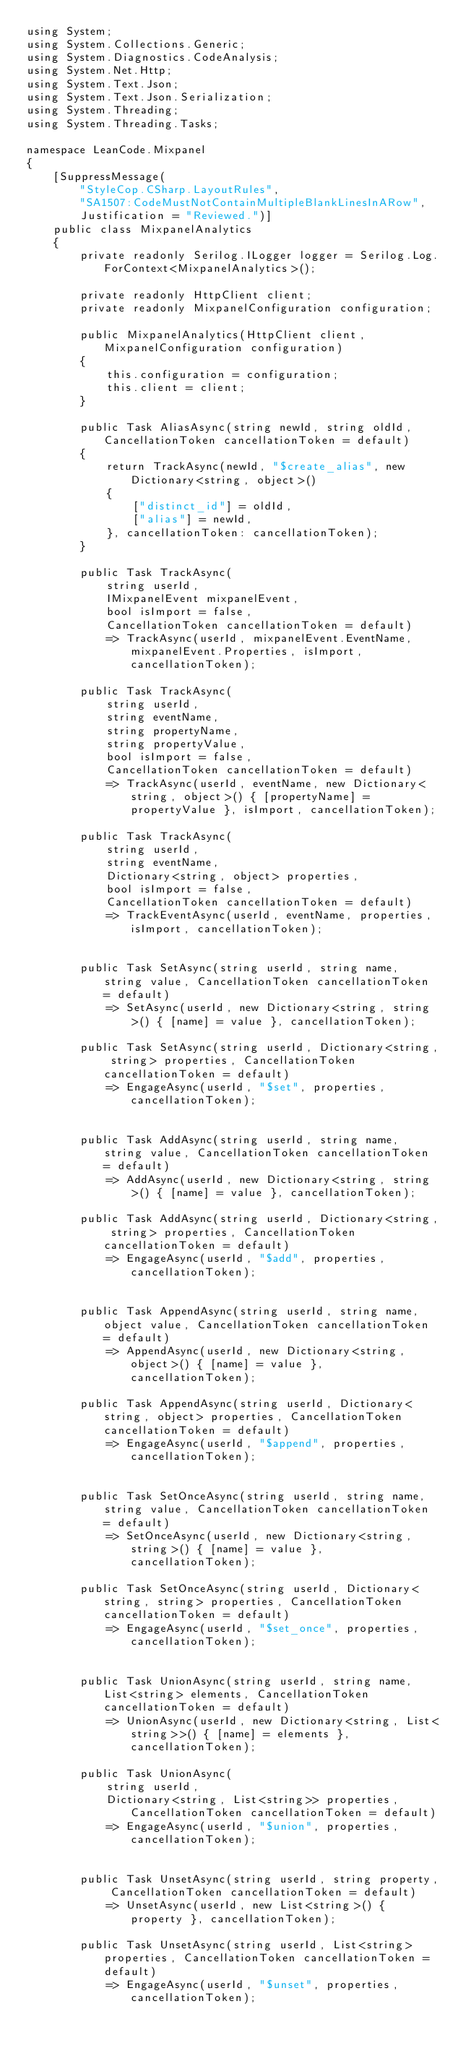Convert code to text. <code><loc_0><loc_0><loc_500><loc_500><_C#_>using System;
using System.Collections.Generic;
using System.Diagnostics.CodeAnalysis;
using System.Net.Http;
using System.Text.Json;
using System.Text.Json.Serialization;
using System.Threading;
using System.Threading.Tasks;

namespace LeanCode.Mixpanel
{
    [SuppressMessage(
        "StyleCop.CSharp.LayoutRules",
        "SA1507:CodeMustNotContainMultipleBlankLinesInARow",
        Justification = "Reviewed.")]
    public class MixpanelAnalytics
    {
        private readonly Serilog.ILogger logger = Serilog.Log.ForContext<MixpanelAnalytics>();

        private readonly HttpClient client;
        private readonly MixpanelConfiguration configuration;

        public MixpanelAnalytics(HttpClient client, MixpanelConfiguration configuration)
        {
            this.configuration = configuration;
            this.client = client;
        }

        public Task AliasAsync(string newId, string oldId, CancellationToken cancellationToken = default)
        {
            return TrackAsync(newId, "$create_alias", new Dictionary<string, object>()
            {
                ["distinct_id"] = oldId,
                ["alias"] = newId,
            }, cancellationToken: cancellationToken);
        }

        public Task TrackAsync(
            string userId,
            IMixpanelEvent mixpanelEvent,
            bool isImport = false,
            CancellationToken cancellationToken = default)
            => TrackAsync(userId, mixpanelEvent.EventName, mixpanelEvent.Properties, isImport, cancellationToken);

        public Task TrackAsync(
            string userId,
            string eventName,
            string propertyName,
            string propertyValue,
            bool isImport = false,
            CancellationToken cancellationToken = default)
            => TrackAsync(userId, eventName, new Dictionary<string, object>() { [propertyName] = propertyValue }, isImport, cancellationToken);

        public Task TrackAsync(
            string userId,
            string eventName,
            Dictionary<string, object> properties,
            bool isImport = false,
            CancellationToken cancellationToken = default)
            => TrackEventAsync(userId, eventName, properties, isImport, cancellationToken);


        public Task SetAsync(string userId, string name, string value, CancellationToken cancellationToken = default)
            => SetAsync(userId, new Dictionary<string, string>() { [name] = value }, cancellationToken);

        public Task SetAsync(string userId, Dictionary<string, string> properties, CancellationToken cancellationToken = default)
            => EngageAsync(userId, "$set", properties, cancellationToken);


        public Task AddAsync(string userId, string name, string value, CancellationToken cancellationToken = default)
            => AddAsync(userId, new Dictionary<string, string>() { [name] = value }, cancellationToken);

        public Task AddAsync(string userId, Dictionary<string, string> properties, CancellationToken cancellationToken = default)
            => EngageAsync(userId, "$add", properties, cancellationToken);


        public Task AppendAsync(string userId, string name, object value, CancellationToken cancellationToken = default)
            => AppendAsync(userId, new Dictionary<string, object>() { [name] = value }, cancellationToken);

        public Task AppendAsync(string userId, Dictionary<string, object> properties, CancellationToken cancellationToken = default)
            => EngageAsync(userId, "$append", properties, cancellationToken);


        public Task SetOnceAsync(string userId, string name, string value, CancellationToken cancellationToken = default)
            => SetOnceAsync(userId, new Dictionary<string, string>() { [name] = value }, cancellationToken);

        public Task SetOnceAsync(string userId, Dictionary<string, string> properties, CancellationToken cancellationToken = default)
            => EngageAsync(userId, "$set_once", properties, cancellationToken);


        public Task UnionAsync(string userId, string name, List<string> elements, CancellationToken cancellationToken = default)
            => UnionAsync(userId, new Dictionary<string, List<string>>() { [name] = elements }, cancellationToken);

        public Task UnionAsync(
            string userId,
            Dictionary<string, List<string>> properties, CancellationToken cancellationToken = default)
            => EngageAsync(userId, "$union", properties, cancellationToken);


        public Task UnsetAsync(string userId, string property, CancellationToken cancellationToken = default)
            => UnsetAsync(userId, new List<string>() { property }, cancellationToken);

        public Task UnsetAsync(string userId, List<string> properties, CancellationToken cancellationToken = default)
            => EngageAsync(userId, "$unset", properties, cancellationToken);

</code> 